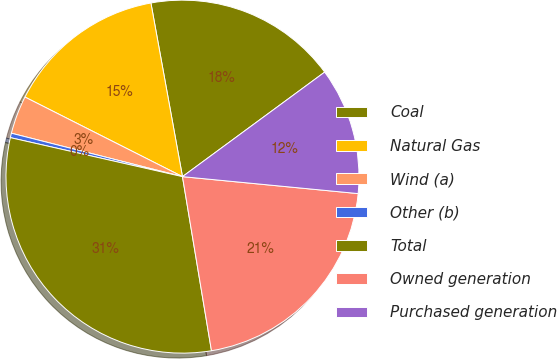Convert chart. <chart><loc_0><loc_0><loc_500><loc_500><pie_chart><fcel>Coal<fcel>Natural Gas<fcel>Wind (a)<fcel>Other (b)<fcel>Total<fcel>Owned generation<fcel>Purchased generation<nl><fcel>17.77%<fcel>14.69%<fcel>3.49%<fcel>0.41%<fcel>31.17%<fcel>20.84%<fcel>11.62%<nl></chart> 